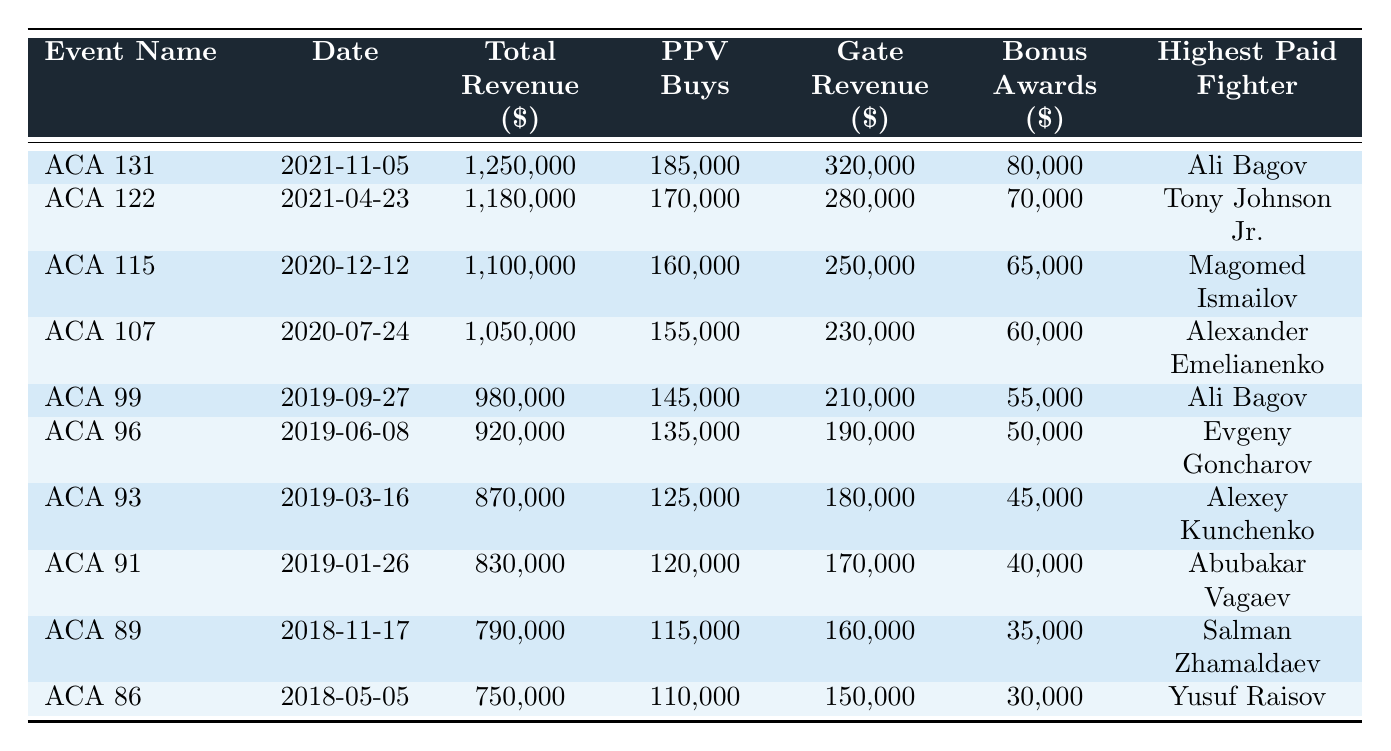What is the total revenue of the event "ACA 131: Abdulvakhabov vs. Dias"? The total revenue for the event "ACA 131: Abdulvakhabov vs. Dias" is provided in the table and is listed as $1,250,000.
Answer: $1,250,000 Which event had the highest number of PPV buys? By comparing the PPV buys for each event in the table, "ACA 131: Abdulvakhabov vs. Dias" has the highest at 185,000 buys.
Answer: 185,000 What is the difference in total revenue between the highest and lowest grossing events? The highest revenue is for "ACA 131: Abdulvakhabov vs. Dias" at $1,250,000 and the lowest is "ACA 86: Balaev vs. Raisov" at $750,000, leading to a difference of $1,250,000 - $750,000 = $500,000.
Answer: $500,000 Which fighter was the highest-paid in the event "ACA 99: Bagov vs. Khaybullaev"? The highest-paid fighter in "ACA 99: Bagov vs. Khaybullaev" is listed as Ali Bagov according to the table.
Answer: Ali Bagov What is the average gate revenue of the top 5 events? First, sum the gate revenues of the top 5 events: $320,000 + $280,000 + $250,000 + $230,000 + $210,000 = $1,290,000. The average is $1,290,000 divided by 5, which equals $258,000.
Answer: $258,000 How many events took place in Moscow, Russia? By scanning the locations, four events (ACA 131, ACA 115, ACA 107, ACA 99) are in Moscow, totalling to four events.
Answer: 4 What percentage of the total revenue does the gate revenue represent for "ACA 122: Johnson vs. Vakhaev"? The total revenue for "ACA 122" is $1,180,000, and the gate revenue is $280,000. To find the percentage: ($280,000 / $1,180,000) * 100% = approximately 23.73%.
Answer: 23.73% Which event had the lowest sponsorship revenue? Comparing the sponsorship revenues in the table, "ACA 86: Balaev vs. Raisov" had the lowest at $75,000.
Answer: $75,000 Is the total revenue for "ACA 91: Agujev vs. Silvério" greater than $800,000? The total revenue for "ACA 91: Agujev vs. Silvério" is $830,000, which is indeed greater than $800,000, therefore the answer is yes.
Answer: Yes What is the sum of the bonus awards for all events? To find the sum, add all the bonus awards: $80,000 + $70,000 + $65,000 + $60,000 + $55,000 + $50,000 + $45,000 + $40,000 + $35,000 + $30,000 = $620,000.
Answer: $620,000 